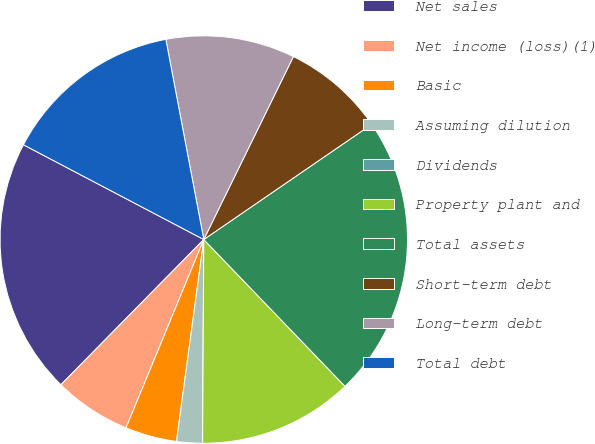<chart> <loc_0><loc_0><loc_500><loc_500><pie_chart><fcel>Net sales<fcel>Net income (loss)(1)<fcel>Basic<fcel>Assuming dilution<fcel>Dividends<fcel>Property plant and<fcel>Total assets<fcel>Short-term debt<fcel>Long-term debt<fcel>Total debt<nl><fcel>20.33%<fcel>6.14%<fcel>4.09%<fcel>2.05%<fcel>0.0%<fcel>12.28%<fcel>22.38%<fcel>8.18%<fcel>10.23%<fcel>14.32%<nl></chart> 